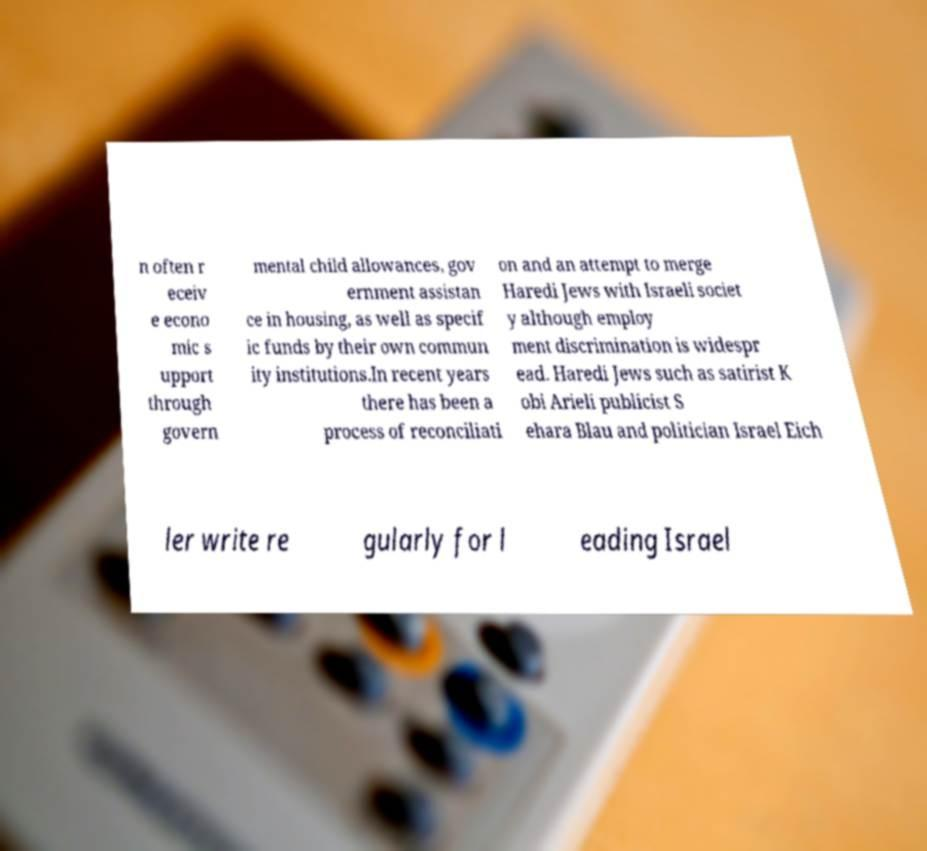Could you assist in decoding the text presented in this image and type it out clearly? n often r eceiv e econo mic s upport through govern mental child allowances, gov ernment assistan ce in housing, as well as specif ic funds by their own commun ity institutions.In recent years there has been a process of reconciliati on and an attempt to merge Haredi Jews with Israeli societ y although employ ment discrimination is widespr ead. Haredi Jews such as satirist K obi Arieli publicist S ehara Blau and politician Israel Eich ler write re gularly for l eading Israel 